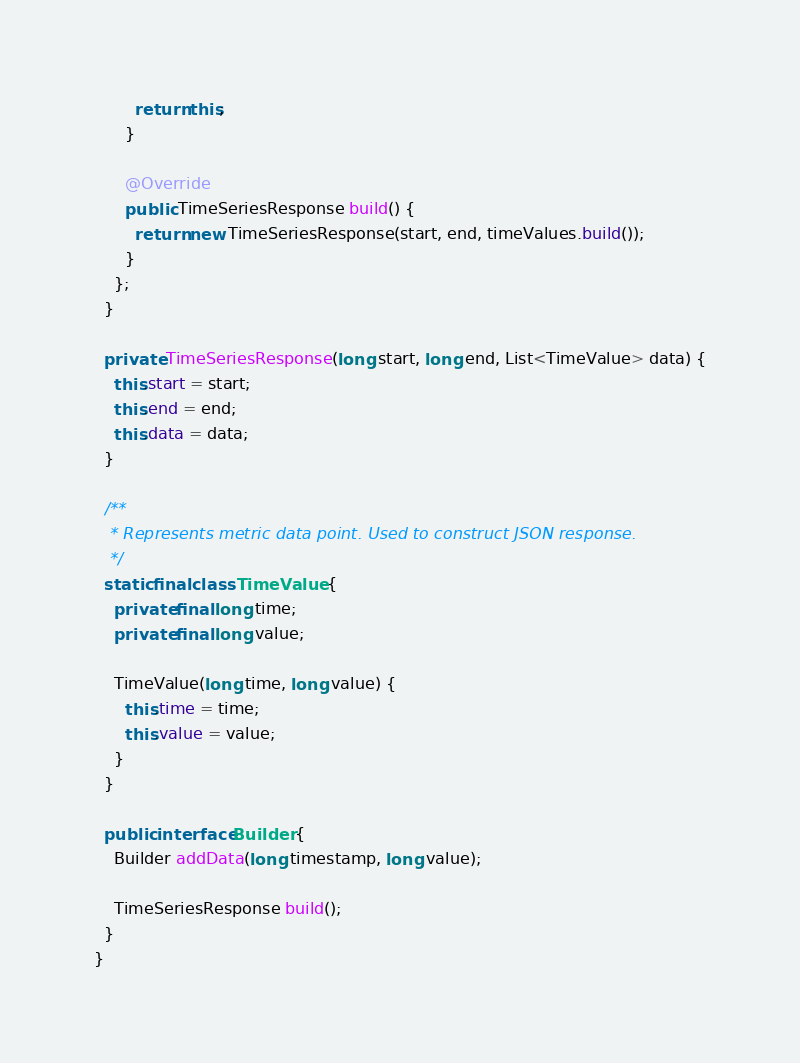<code> <loc_0><loc_0><loc_500><loc_500><_Java_>        return this;
      }

      @Override
      public TimeSeriesResponse build() {
        return new TimeSeriesResponse(start, end, timeValues.build());
      }
    };
  }

  private TimeSeriesResponse(long start, long end, List<TimeValue> data) {
    this.start = start;
    this.end = end;
    this.data = data;
  }

  /**
   * Represents metric data point. Used to construct JSON response.
   */
  static final class TimeValue {
    private final long time;
    private final long value;

    TimeValue(long time, long value) {
      this.time = time;
      this.value = value;
    }
  }

  public interface Builder {
    Builder addData(long timestamp, long value);

    TimeSeriesResponse build();
  }
}
</code> 